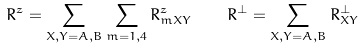<formula> <loc_0><loc_0><loc_500><loc_500>R ^ { z } = \sum _ { X , Y = A , B } \sum _ { m = 1 , 4 } R _ { m X Y } ^ { z } \quad R ^ { \perp } = \sum _ { X , Y = A , B } R _ { X Y } ^ { \perp }</formula> 